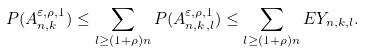Convert formula to latex. <formula><loc_0><loc_0><loc_500><loc_500>P ( A _ { n , k } ^ { \varepsilon , \rho , 1 } ) \leq \sum _ { l \geq ( 1 + \rho ) n } P ( A _ { n , k , l } ^ { \varepsilon , \rho , 1 } ) \leq \sum _ { l \geq ( 1 + \rho ) n } E Y _ { n , k , l } .</formula> 